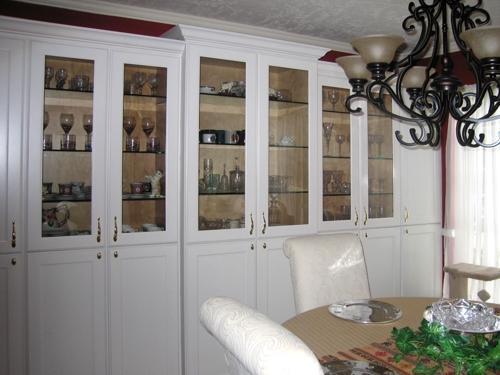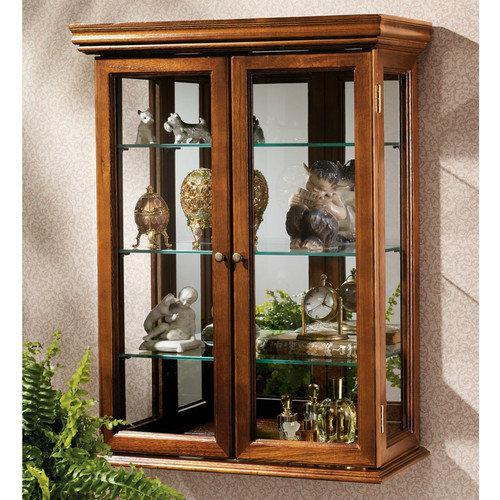The first image is the image on the left, the second image is the image on the right. Assess this claim about the two images: "A large china cupboard unit in one image is built flush with the wall, with solid doors at the bottom and glass doors at the top.". Correct or not? Answer yes or no. Yes. The first image is the image on the left, the second image is the image on the right. Considering the images on both sides, is "One image shows a bright white cabinet with a flat top." valid? Answer yes or no. Yes. 